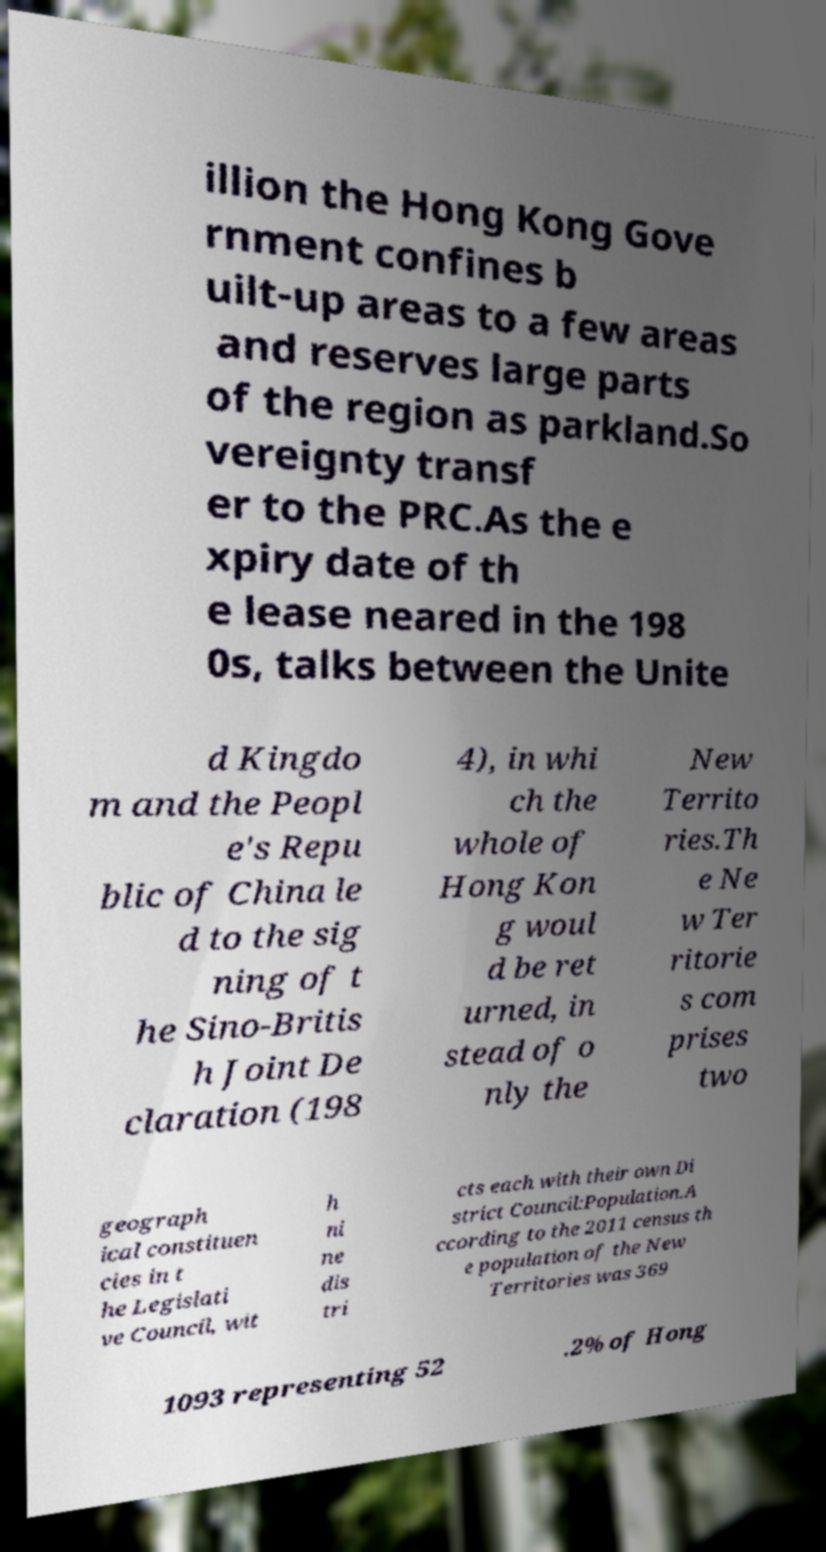Can you accurately transcribe the text from the provided image for me? illion the Hong Kong Gove rnment confines b uilt-up areas to a few areas and reserves large parts of the region as parkland.So vereignty transf er to the PRC.As the e xpiry date of th e lease neared in the 198 0s, talks between the Unite d Kingdo m and the Peopl e's Repu blic of China le d to the sig ning of t he Sino-Britis h Joint De claration (198 4), in whi ch the whole of Hong Kon g woul d be ret urned, in stead of o nly the New Territo ries.Th e Ne w Ter ritorie s com prises two geograph ical constituen cies in t he Legislati ve Council, wit h ni ne dis tri cts each with their own Di strict Council:Population.A ccording to the 2011 census th e population of the New Territories was 369 1093 representing 52 .2% of Hong 